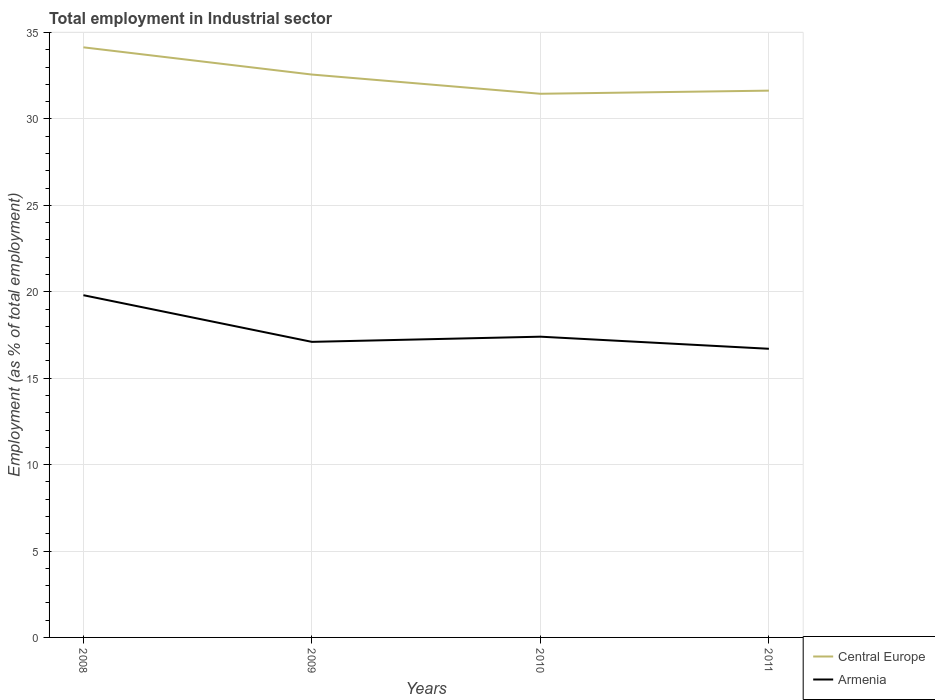How many different coloured lines are there?
Ensure brevity in your answer.  2. Does the line corresponding to Central Europe intersect with the line corresponding to Armenia?
Offer a very short reply. No. Across all years, what is the maximum employment in industrial sector in Central Europe?
Your answer should be compact. 31.45. What is the total employment in industrial sector in Armenia in the graph?
Make the answer very short. 0.7. What is the difference between the highest and the second highest employment in industrial sector in Central Europe?
Provide a succinct answer. 2.69. How many lines are there?
Provide a short and direct response. 2. What is the difference between two consecutive major ticks on the Y-axis?
Ensure brevity in your answer.  5. Does the graph contain any zero values?
Make the answer very short. No. How many legend labels are there?
Offer a very short reply. 2. What is the title of the graph?
Your answer should be compact. Total employment in Industrial sector. What is the label or title of the Y-axis?
Ensure brevity in your answer.  Employment (as % of total employment). What is the Employment (as % of total employment) of Central Europe in 2008?
Make the answer very short. 34.14. What is the Employment (as % of total employment) in Armenia in 2008?
Your answer should be very brief. 19.8. What is the Employment (as % of total employment) in Central Europe in 2009?
Offer a terse response. 32.57. What is the Employment (as % of total employment) of Armenia in 2009?
Ensure brevity in your answer.  17.1. What is the Employment (as % of total employment) of Central Europe in 2010?
Offer a terse response. 31.45. What is the Employment (as % of total employment) of Armenia in 2010?
Keep it short and to the point. 17.4. What is the Employment (as % of total employment) of Central Europe in 2011?
Your answer should be compact. 31.63. What is the Employment (as % of total employment) in Armenia in 2011?
Your answer should be very brief. 16.7. Across all years, what is the maximum Employment (as % of total employment) in Central Europe?
Ensure brevity in your answer.  34.14. Across all years, what is the maximum Employment (as % of total employment) in Armenia?
Your answer should be very brief. 19.8. Across all years, what is the minimum Employment (as % of total employment) of Central Europe?
Your answer should be very brief. 31.45. Across all years, what is the minimum Employment (as % of total employment) in Armenia?
Offer a very short reply. 16.7. What is the total Employment (as % of total employment) of Central Europe in the graph?
Offer a very short reply. 129.8. What is the total Employment (as % of total employment) of Armenia in the graph?
Offer a very short reply. 71. What is the difference between the Employment (as % of total employment) in Central Europe in 2008 and that in 2009?
Ensure brevity in your answer.  1.58. What is the difference between the Employment (as % of total employment) of Central Europe in 2008 and that in 2010?
Provide a succinct answer. 2.69. What is the difference between the Employment (as % of total employment) in Armenia in 2008 and that in 2010?
Your answer should be compact. 2.4. What is the difference between the Employment (as % of total employment) of Central Europe in 2008 and that in 2011?
Ensure brevity in your answer.  2.51. What is the difference between the Employment (as % of total employment) in Armenia in 2008 and that in 2011?
Make the answer very short. 3.1. What is the difference between the Employment (as % of total employment) in Central Europe in 2009 and that in 2010?
Give a very brief answer. 1.11. What is the difference between the Employment (as % of total employment) of Armenia in 2009 and that in 2010?
Ensure brevity in your answer.  -0.3. What is the difference between the Employment (as % of total employment) of Central Europe in 2010 and that in 2011?
Keep it short and to the point. -0.18. What is the difference between the Employment (as % of total employment) in Armenia in 2010 and that in 2011?
Your answer should be very brief. 0.7. What is the difference between the Employment (as % of total employment) of Central Europe in 2008 and the Employment (as % of total employment) of Armenia in 2009?
Your answer should be compact. 17.04. What is the difference between the Employment (as % of total employment) in Central Europe in 2008 and the Employment (as % of total employment) in Armenia in 2010?
Keep it short and to the point. 16.74. What is the difference between the Employment (as % of total employment) of Central Europe in 2008 and the Employment (as % of total employment) of Armenia in 2011?
Provide a succinct answer. 17.44. What is the difference between the Employment (as % of total employment) of Central Europe in 2009 and the Employment (as % of total employment) of Armenia in 2010?
Your answer should be very brief. 15.17. What is the difference between the Employment (as % of total employment) of Central Europe in 2009 and the Employment (as % of total employment) of Armenia in 2011?
Provide a succinct answer. 15.87. What is the difference between the Employment (as % of total employment) in Central Europe in 2010 and the Employment (as % of total employment) in Armenia in 2011?
Offer a very short reply. 14.75. What is the average Employment (as % of total employment) in Central Europe per year?
Your answer should be very brief. 32.45. What is the average Employment (as % of total employment) of Armenia per year?
Make the answer very short. 17.75. In the year 2008, what is the difference between the Employment (as % of total employment) in Central Europe and Employment (as % of total employment) in Armenia?
Make the answer very short. 14.34. In the year 2009, what is the difference between the Employment (as % of total employment) of Central Europe and Employment (as % of total employment) of Armenia?
Your response must be concise. 15.47. In the year 2010, what is the difference between the Employment (as % of total employment) of Central Europe and Employment (as % of total employment) of Armenia?
Your answer should be compact. 14.05. In the year 2011, what is the difference between the Employment (as % of total employment) in Central Europe and Employment (as % of total employment) in Armenia?
Provide a short and direct response. 14.93. What is the ratio of the Employment (as % of total employment) in Central Europe in 2008 to that in 2009?
Ensure brevity in your answer.  1.05. What is the ratio of the Employment (as % of total employment) in Armenia in 2008 to that in 2009?
Ensure brevity in your answer.  1.16. What is the ratio of the Employment (as % of total employment) of Central Europe in 2008 to that in 2010?
Make the answer very short. 1.09. What is the ratio of the Employment (as % of total employment) of Armenia in 2008 to that in 2010?
Make the answer very short. 1.14. What is the ratio of the Employment (as % of total employment) of Central Europe in 2008 to that in 2011?
Ensure brevity in your answer.  1.08. What is the ratio of the Employment (as % of total employment) of Armenia in 2008 to that in 2011?
Give a very brief answer. 1.19. What is the ratio of the Employment (as % of total employment) of Central Europe in 2009 to that in 2010?
Make the answer very short. 1.04. What is the ratio of the Employment (as % of total employment) in Armenia in 2009 to that in 2010?
Offer a terse response. 0.98. What is the ratio of the Employment (as % of total employment) in Central Europe in 2009 to that in 2011?
Keep it short and to the point. 1.03. What is the ratio of the Employment (as % of total employment) of Central Europe in 2010 to that in 2011?
Your answer should be compact. 0.99. What is the ratio of the Employment (as % of total employment) in Armenia in 2010 to that in 2011?
Your response must be concise. 1.04. What is the difference between the highest and the second highest Employment (as % of total employment) of Central Europe?
Provide a short and direct response. 1.58. What is the difference between the highest and the lowest Employment (as % of total employment) of Central Europe?
Provide a short and direct response. 2.69. What is the difference between the highest and the lowest Employment (as % of total employment) of Armenia?
Provide a succinct answer. 3.1. 